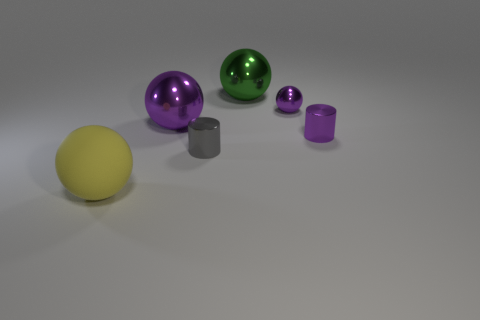What is the texture of the objects and how does it contribute to the overall mood of the image? All objects in the image have a smooth, matte finish which gives the scene a calm and simplistic aesthetic. The subtle shadows and soft lighting also contribute to the serene mood. 